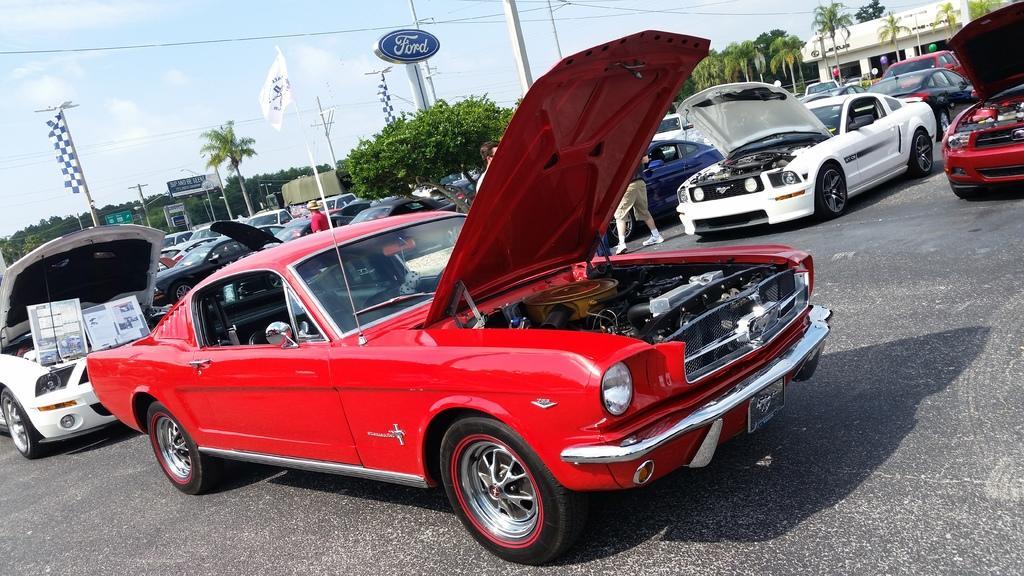Can you describe this image briefly? In this image we can see the red color car where car bonnet is open ended and we can see few cars where car bonnets are opened. Here we can see a person standing, we can see a few more cars parked here, we can see trees, flags, boards, banners, house, wires and the sky with clouds in the background. 